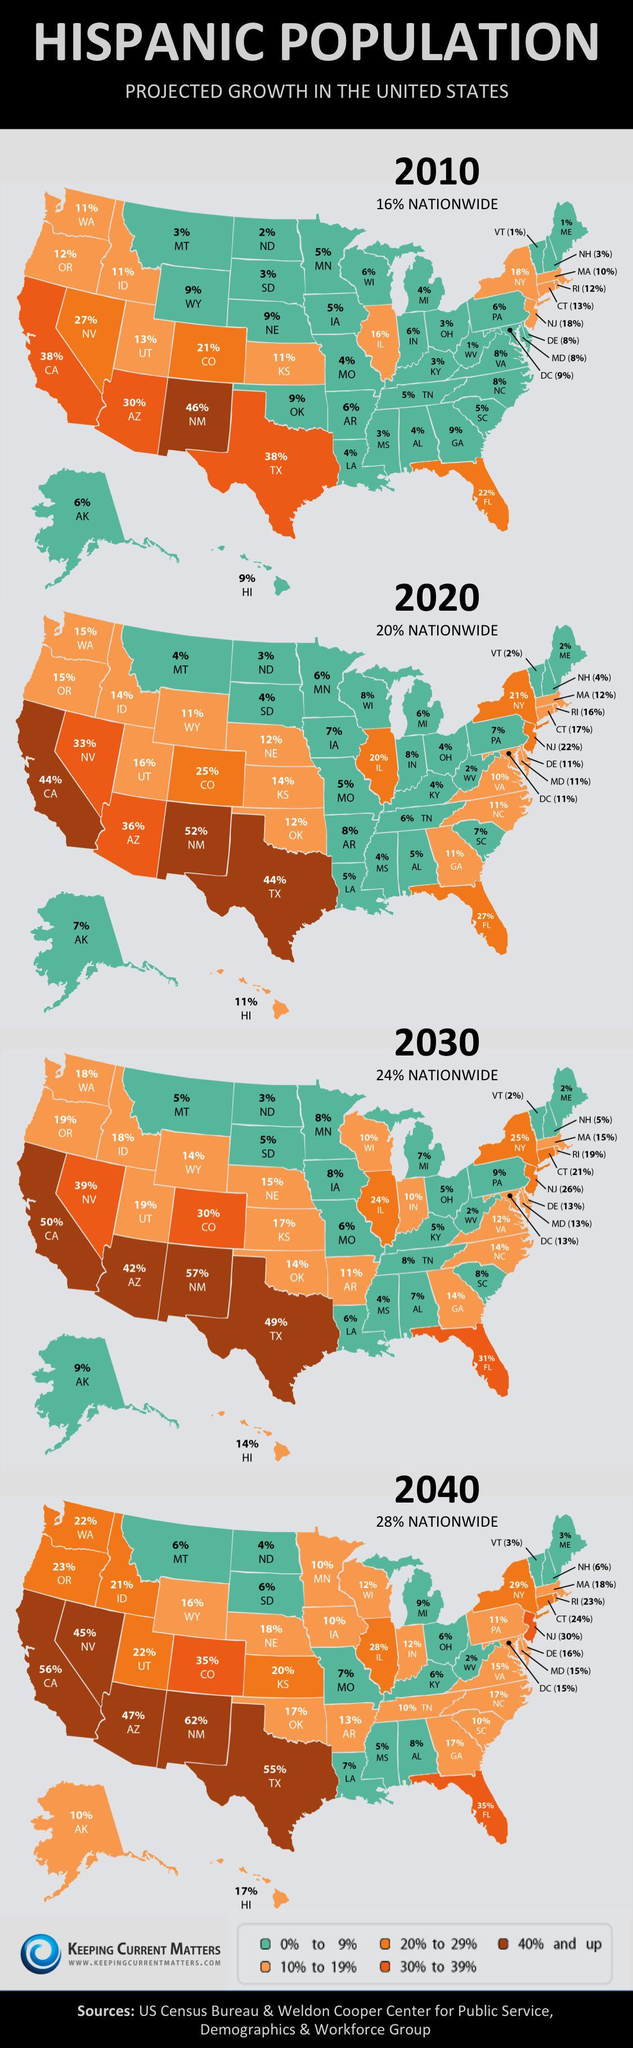What is the projected growth percentage of the Hispanic population in Alaska in 2010?
Answer the question with a short phrase. 6% Which state in the U.S. has the second-highest projected growth percentage of the Hispanic population in 2040? CA Which state in the U.S. has the highest projected growth percentage of the Hispanic population in 2020? NM What is the projected growth percentage of the Hispanic population in Texas in 2030? 49% 